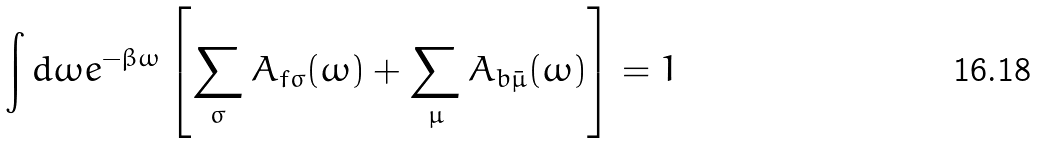Convert formula to latex. <formula><loc_0><loc_0><loc_500><loc_500>\int { d } \omega e ^ { - \beta \omega } \left [ \sum _ { \sigma } A _ { f \sigma } ( \omega ) + \sum _ { \mu } A _ { b \bar { \mu } } ( \omega ) \right ] = 1</formula> 